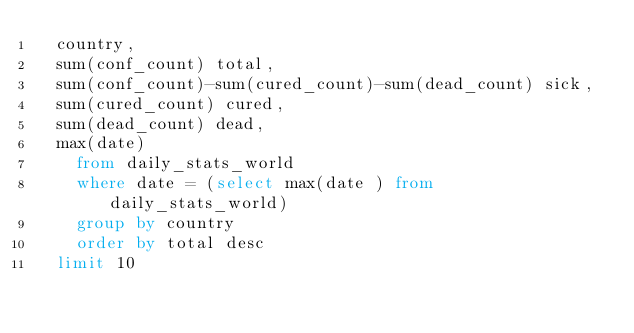Convert code to text. <code><loc_0><loc_0><loc_500><loc_500><_SQL_>	country, 
	sum(conf_count) total,
	sum(conf_count)-sum(cured_count)-sum(dead_count) sick, 
	sum(cured_count) cured, 
	sum(dead_count) dead,
	max(date)
    from daily_stats_world 
    where date = (select max(date ) from daily_stats_world) 
    group by country 
    order by total desc 
	limit 10</code> 